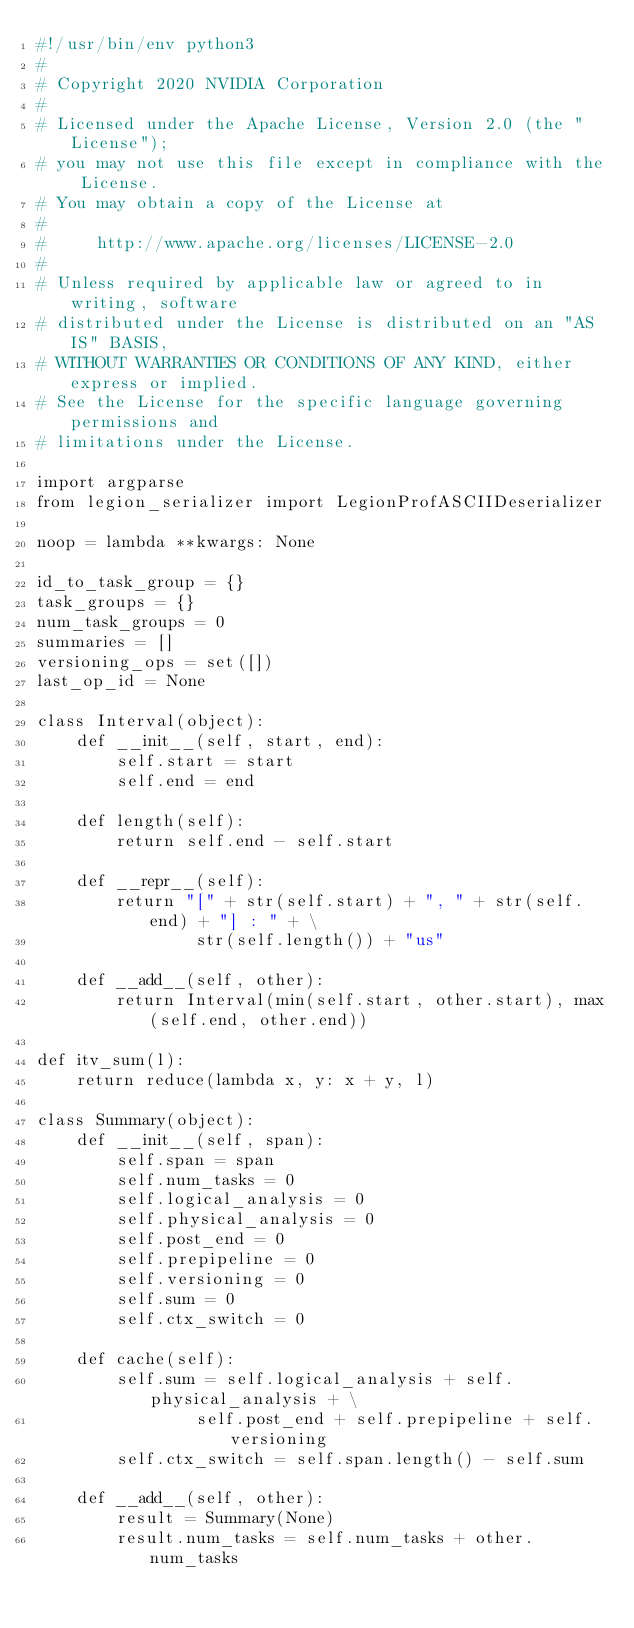Convert code to text. <code><loc_0><loc_0><loc_500><loc_500><_Python_>#!/usr/bin/env python3
#
# Copyright 2020 NVIDIA Corporation
#
# Licensed under the Apache License, Version 2.0 (the "License");
# you may not use this file except in compliance with the License.
# You may obtain a copy of the License at
#
#     http://www.apache.org/licenses/LICENSE-2.0
#
# Unless required by applicable law or agreed to in writing, software
# distributed under the License is distributed on an "AS IS" BASIS,
# WITHOUT WARRANTIES OR CONDITIONS OF ANY KIND, either express or implied.
# See the License for the specific language governing permissions and
# limitations under the License.

import argparse
from legion_serializer import LegionProfASCIIDeserializer

noop = lambda **kwargs: None

id_to_task_group = {}
task_groups = {}
num_task_groups = 0
summaries = []
versioning_ops = set([])
last_op_id = None

class Interval(object):
    def __init__(self, start, end):
        self.start = start
        self.end = end

    def length(self):
        return self.end - self.start

    def __repr__(self):
        return "[" + str(self.start) + ", " + str(self.end) + "] : " + \
                str(self.length()) + "us"

    def __add__(self, other):
        return Interval(min(self.start, other.start), max(self.end, other.end))

def itv_sum(l):
    return reduce(lambda x, y: x + y, l)

class Summary(object):
    def __init__(self, span):
        self.span = span
        self.num_tasks = 0
        self.logical_analysis = 0
        self.physical_analysis = 0
        self.post_end = 0
        self.prepipeline = 0
        self.versioning = 0
        self.sum = 0
        self.ctx_switch = 0

    def cache(self):
        self.sum = self.logical_analysis + self.physical_analysis + \
                self.post_end + self.prepipeline + self.versioning
        self.ctx_switch = self.span.length() - self.sum

    def __add__(self, other):
        result = Summary(None)
        result.num_tasks = self.num_tasks + other.num_tasks</code> 